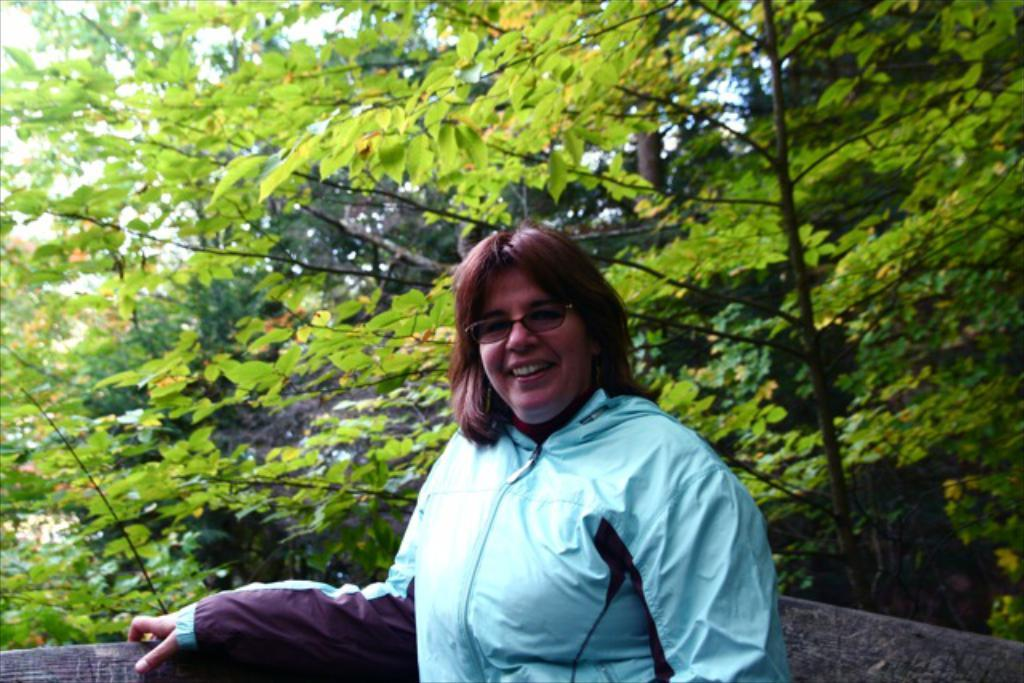Who is the main subject in the image? There is a woman in the image. What is the woman wearing? The woman is wearing a jacket. What is the woman's facial expression in the image? The woman is smiling. What is the woman doing in the image? The woman is giving a pose for the picture. What can be seen beside the woman in the image? There is a wooden object beside the woman. What is visible in the background of the image? There are many trees in the background of the image. Can you see a stream of jelly flowing beside the woman in the image? No, there is no stream of jelly visible in the image. What type of gate is present in the image? There is no gate present in the image. 